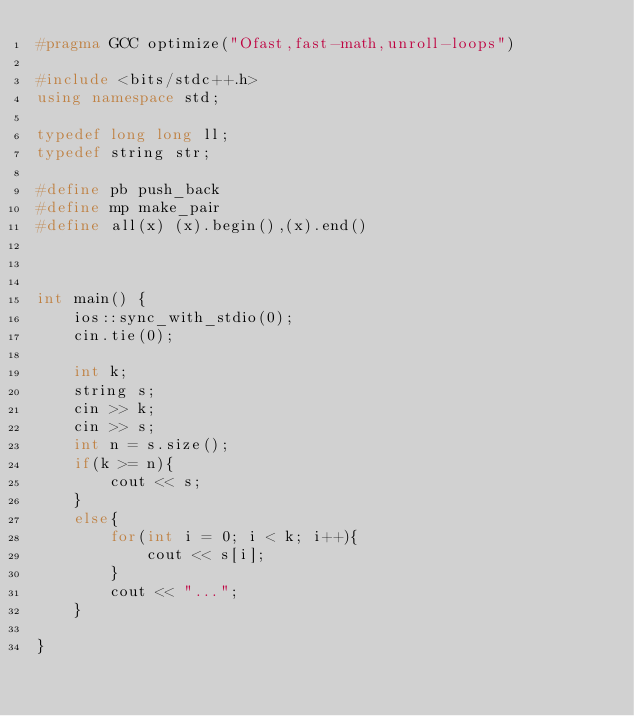<code> <loc_0><loc_0><loc_500><loc_500><_C++_>#pragma GCC optimize("Ofast,fast-math,unroll-loops")

#include <bits/stdc++.h>
using namespace std;

typedef long long ll;
typedef string str;

#define pb push_back
#define mp make_pair
#define all(x) (x).begin(),(x).end()



int main() {
    ios::sync_with_stdio(0);
    cin.tie(0);
	
	int k;
	string s;
	cin >> k;
	cin >> s;
	int n = s.size();
	if(k >= n){
		cout << s;
	}
	else{
		for(int i = 0; i < k; i++){
			cout << s[i];
		}
		cout << "...";
	}

}
</code> 